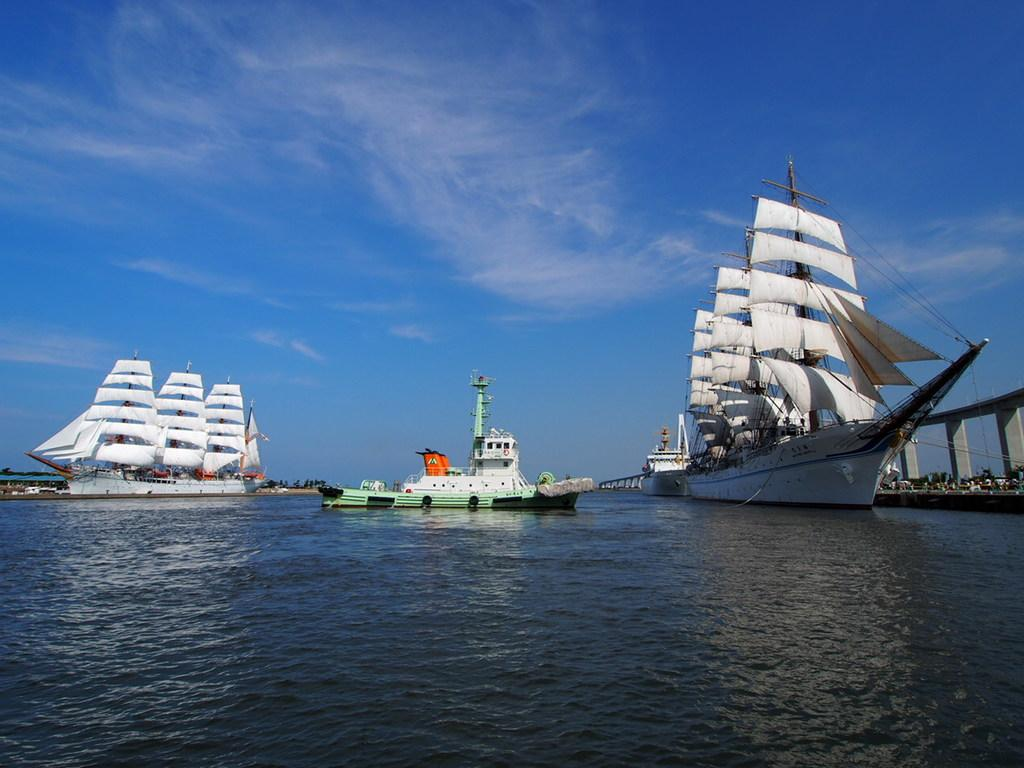What is the main subject of the image? The main subject of the image is three ships. What are the ships doing in the image? The ships are sailing on the water. What can be seen on the right side of the image? There is a bridge on the right side of the image. How would you describe the weather in the image? The sky is clear in the image, suggesting good weather. What type of cushion can be seen on the deck of the ships in the image? There are no cushions visible on the ships in the image. How does the earthquake affect the ships in the image? There is no earthquake present in the image, so its effects cannot be observed. 